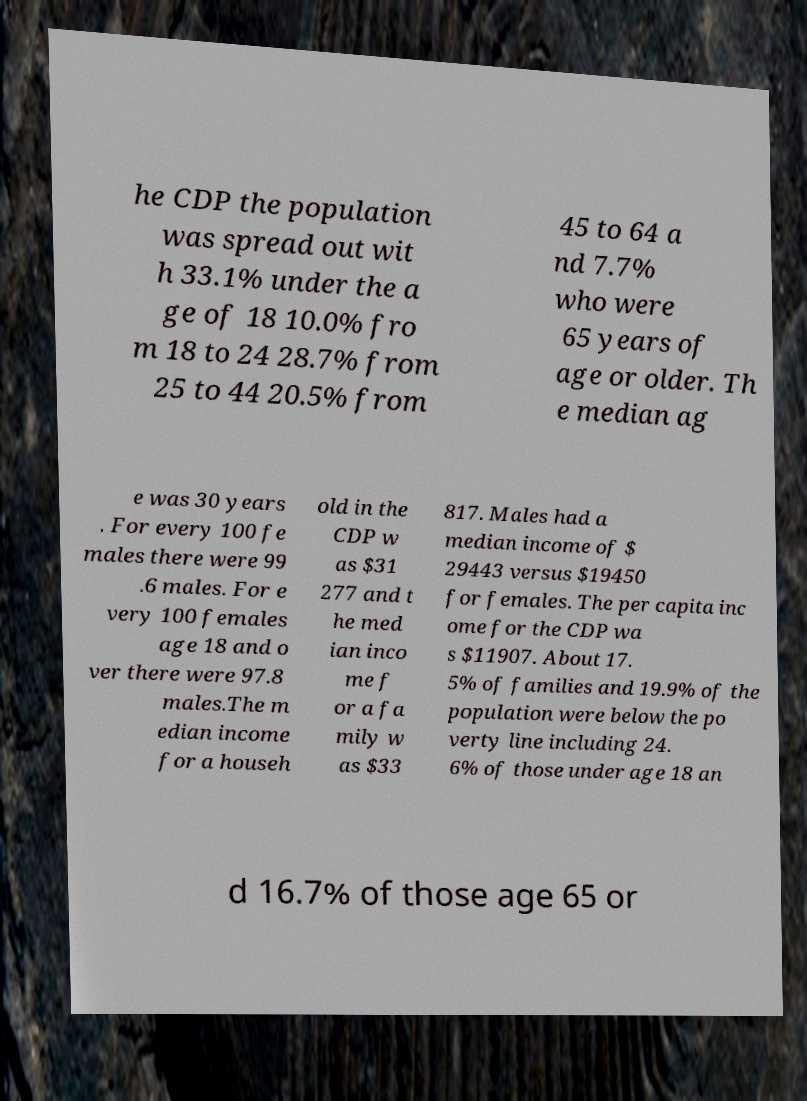Can you accurately transcribe the text from the provided image for me? he CDP the population was spread out wit h 33.1% under the a ge of 18 10.0% fro m 18 to 24 28.7% from 25 to 44 20.5% from 45 to 64 a nd 7.7% who were 65 years of age or older. Th e median ag e was 30 years . For every 100 fe males there were 99 .6 males. For e very 100 females age 18 and o ver there were 97.8 males.The m edian income for a househ old in the CDP w as $31 277 and t he med ian inco me f or a fa mily w as $33 817. Males had a median income of $ 29443 versus $19450 for females. The per capita inc ome for the CDP wa s $11907. About 17. 5% of families and 19.9% of the population were below the po verty line including 24. 6% of those under age 18 an d 16.7% of those age 65 or 